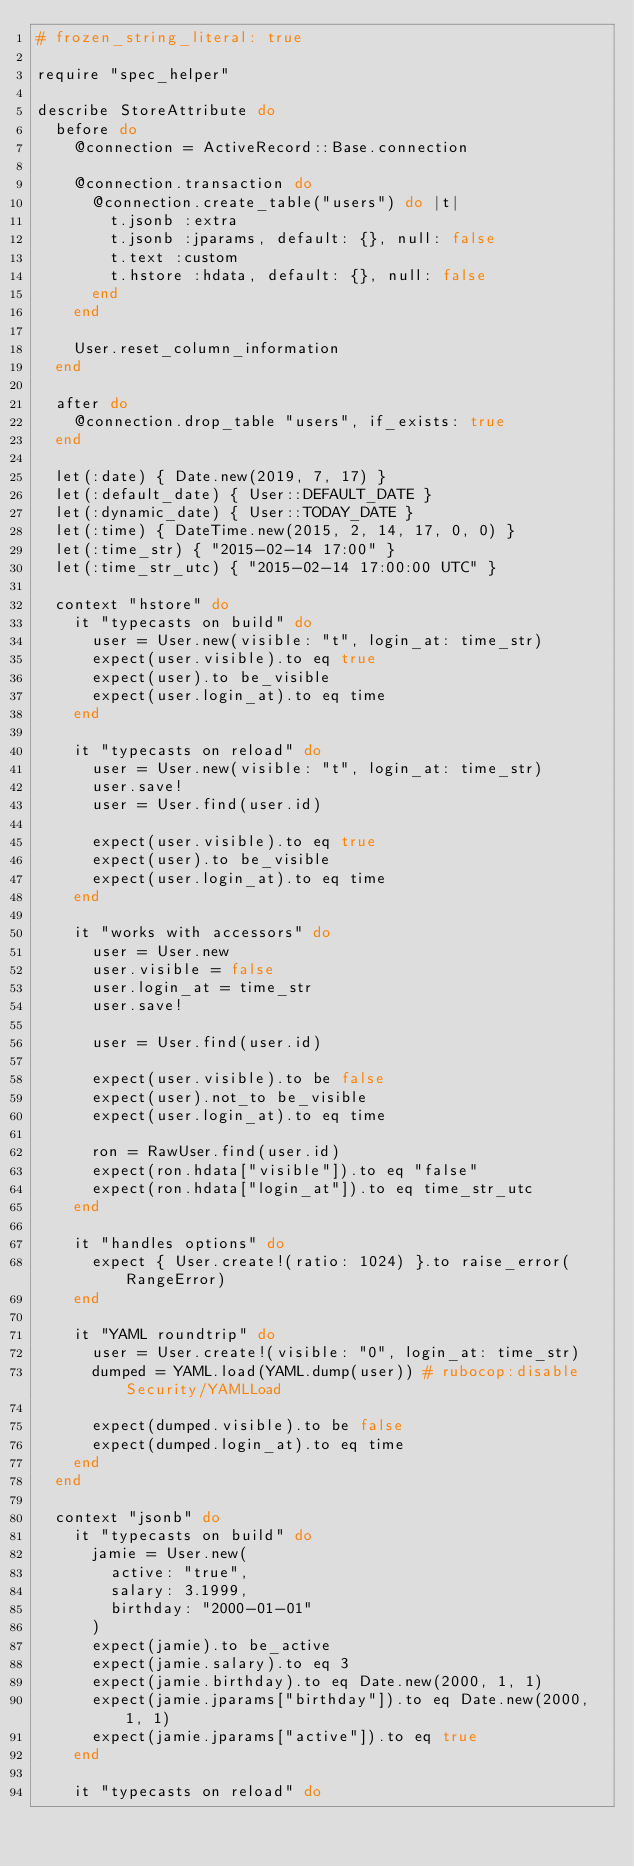Convert code to text. <code><loc_0><loc_0><loc_500><loc_500><_Ruby_># frozen_string_literal: true

require "spec_helper"

describe StoreAttribute do
  before do
    @connection = ActiveRecord::Base.connection

    @connection.transaction do
      @connection.create_table("users") do |t|
        t.jsonb :extra
        t.jsonb :jparams, default: {}, null: false
        t.text :custom
        t.hstore :hdata, default: {}, null: false
      end
    end

    User.reset_column_information
  end

  after do
    @connection.drop_table "users", if_exists: true
  end

  let(:date) { Date.new(2019, 7, 17) }
  let(:default_date) { User::DEFAULT_DATE }
  let(:dynamic_date) { User::TODAY_DATE }
  let(:time) { DateTime.new(2015, 2, 14, 17, 0, 0) }
  let(:time_str) { "2015-02-14 17:00" }
  let(:time_str_utc) { "2015-02-14 17:00:00 UTC" }

  context "hstore" do
    it "typecasts on build" do
      user = User.new(visible: "t", login_at: time_str)
      expect(user.visible).to eq true
      expect(user).to be_visible
      expect(user.login_at).to eq time
    end

    it "typecasts on reload" do
      user = User.new(visible: "t", login_at: time_str)
      user.save!
      user = User.find(user.id)

      expect(user.visible).to eq true
      expect(user).to be_visible
      expect(user.login_at).to eq time
    end

    it "works with accessors" do
      user = User.new
      user.visible = false
      user.login_at = time_str
      user.save!

      user = User.find(user.id)

      expect(user.visible).to be false
      expect(user).not_to be_visible
      expect(user.login_at).to eq time

      ron = RawUser.find(user.id)
      expect(ron.hdata["visible"]).to eq "false"
      expect(ron.hdata["login_at"]).to eq time_str_utc
    end

    it "handles options" do
      expect { User.create!(ratio: 1024) }.to raise_error(RangeError)
    end

    it "YAML roundtrip" do
      user = User.create!(visible: "0", login_at: time_str)
      dumped = YAML.load(YAML.dump(user)) # rubocop:disable Security/YAMLLoad

      expect(dumped.visible).to be false
      expect(dumped.login_at).to eq time
    end
  end

  context "jsonb" do
    it "typecasts on build" do
      jamie = User.new(
        active: "true",
        salary: 3.1999,
        birthday: "2000-01-01"
      )
      expect(jamie).to be_active
      expect(jamie.salary).to eq 3
      expect(jamie.birthday).to eq Date.new(2000, 1, 1)
      expect(jamie.jparams["birthday"]).to eq Date.new(2000, 1, 1)
      expect(jamie.jparams["active"]).to eq true
    end

    it "typecasts on reload" do</code> 